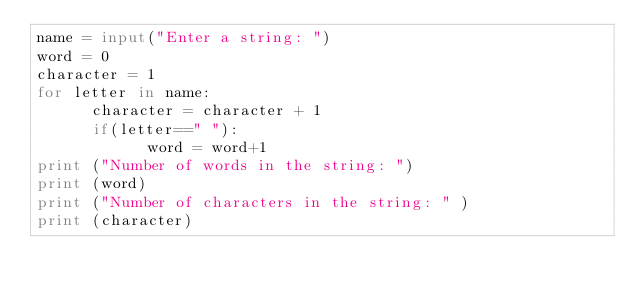<code> <loc_0><loc_0><loc_500><loc_500><_Python_>name = input("Enter a string: ")
word = 0
character = 1
for letter in name: 
      character = character + 1
      if(letter==" "):
            word = word+1
print ("Number of words in the string: ")
print (word)
print ("Number of characters in the string: " )
print (character)
</code> 